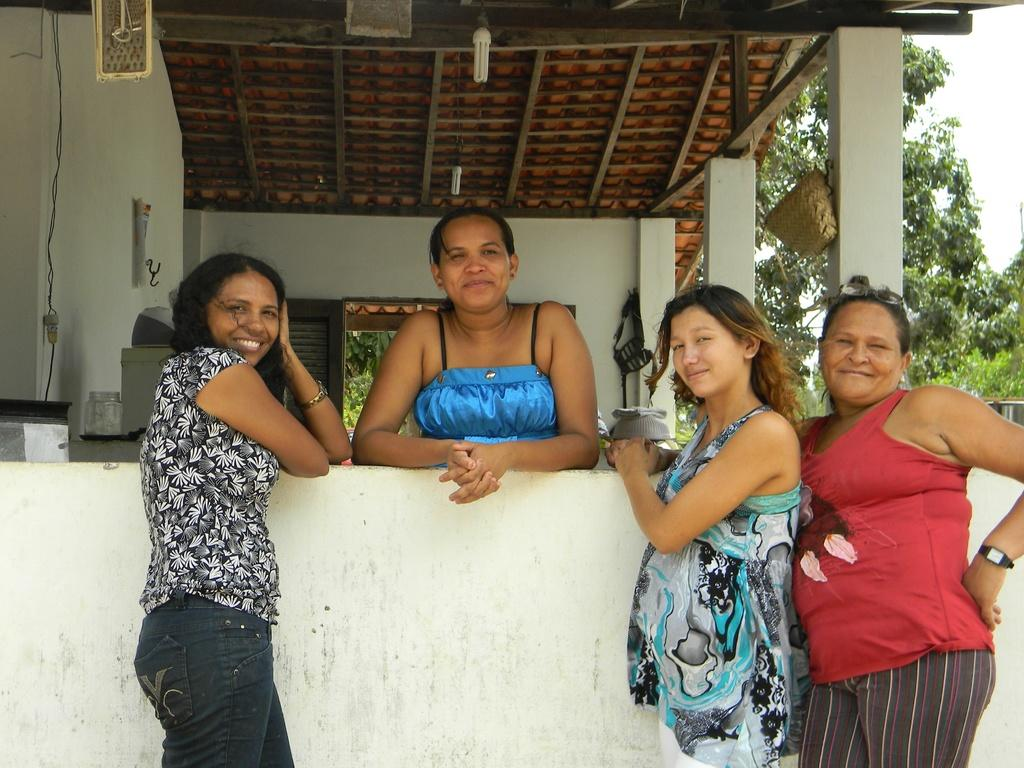What can be seen in the image? There are women standing in the image, along with a house, trees, lights, and the sky. Can you describe the women in the image? The provided facts do not give specific details about the women, so we cannot describe them further. What type of structure is visible in the image? There is a house in the image. What else can be seen in the image besides the house? There are trees, lights, and the sky visible in the image. What advice is the ghost giving to the women in the image? There is no ghost present in the image, so no advice can be given. Are the police involved in the scene depicted in the image? The provided facts do not mention the presence of police, so we cannot determine their involvement. 